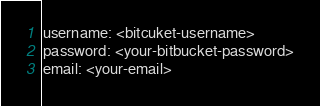Convert code to text. <code><loc_0><loc_0><loc_500><loc_500><_YAML_>username: <bitcuket-username>
password: <your-bitbucket-password>
email: <your-email>
</code> 